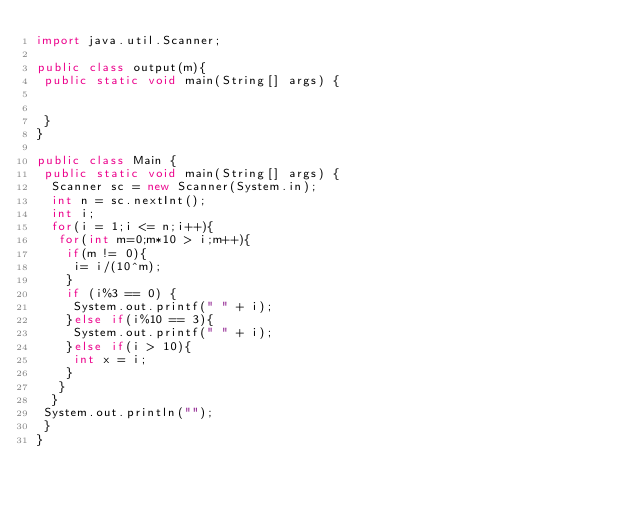<code> <loc_0><loc_0><loc_500><loc_500><_Java_>import java.util.Scanner;

public class output(m){
 public static void main(String[] args) {
 

 }
}

public class Main {
 public static void main(String[] args) {
  Scanner sc = new Scanner(System.in);
  int n = sc.nextInt();
  int i;
  for(i = 1;i <= n;i++){
   for(int m=0;m*10 > i;m++){
    if(m != 0){
     i= i/(10^m);
    }
    if (i%3 == 0) {
     System.out.printf(" " + i);
    }else if(i%10 == 3){
     System.out.printf(" " + i);
    }else if(i > 10){
     int x = i;
    }
   }
  }
 System.out.println("");
 }
}</code> 